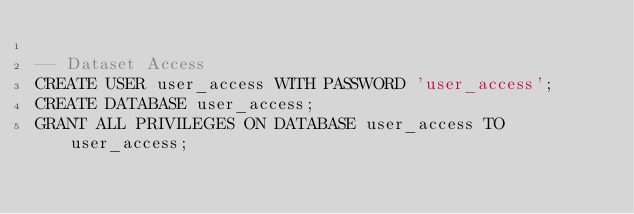<code> <loc_0><loc_0><loc_500><loc_500><_SQL_>
-- Dataset Access
CREATE USER user_access WITH PASSWORD 'user_access';
CREATE DATABASE user_access;
GRANT ALL PRIVILEGES ON DATABASE user_access TO user_access;
</code> 